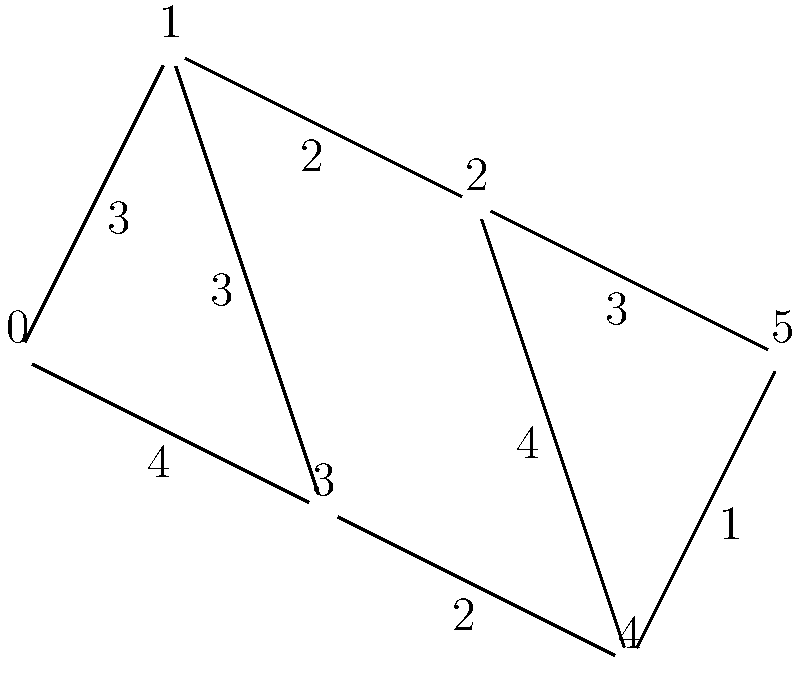As a dedicated runner, you're planning a route through a city represented by the network diagram above. Each node represents a landmark, and the edges represent roads with their distances in kilometers. Starting from node 0, what is the shortest distance to reach node 5, and which path should you take to optimize your training? To find the shortest path from node 0 to node 5, we'll use Dijkstra's algorithm:

1. Initialize distances: $d[0]=0$, all others $\infty$
2. Set all nodes as unvisited
3. For the current node, consider all unvisited neighbors and calculate their tentative distances
4. Update the neighbor's distance if the calculated distance is less than the previously recorded distance
5. Mark the current node as visited and remove it from the unvisited set
6. If the destination node has been marked visited, we're done. Otherwise, select the unvisited node with the smallest tentative distance and repeat from step 3

Following these steps:

1. Start at node 0: $d[0]=0$
2. Update neighbors: $d[1]=3$, $d[3]=4$
3. Visit node 1: update $d[2]=5$, $d[3]$ remains 4
4. Visit node 3: update $d[4]=6$
5. Visit node 2: $d[4]$ remains 6, update $d[5]=8$
6. Visit node 4: update $d[5]=7$
7. Visit node 5: algorithm complete

The shortest path is 0 -> 1 -> 3 -> 4 -> 5, with a total distance of 7 km.
Answer: 7 km; Path: 0 -> 1 -> 3 -> 4 -> 5 